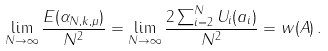<formula> <loc_0><loc_0><loc_500><loc_500>\lim _ { N \rightarrow \infty } \frac { E ( \alpha _ { N , k , \mu } ) } { N ^ { 2 } } = \lim _ { N \rightarrow \infty } \frac { 2 \sum _ { i = 2 } ^ { N } U _ { i } ( a _ { i } ) } { N ^ { 2 } } = w ( A ) \, .</formula> 